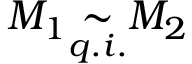Convert formula to latex. <formula><loc_0><loc_0><loc_500><loc_500>M _ { 1 } { \underset { q . i . } { \sim } } M _ { 2 }</formula> 